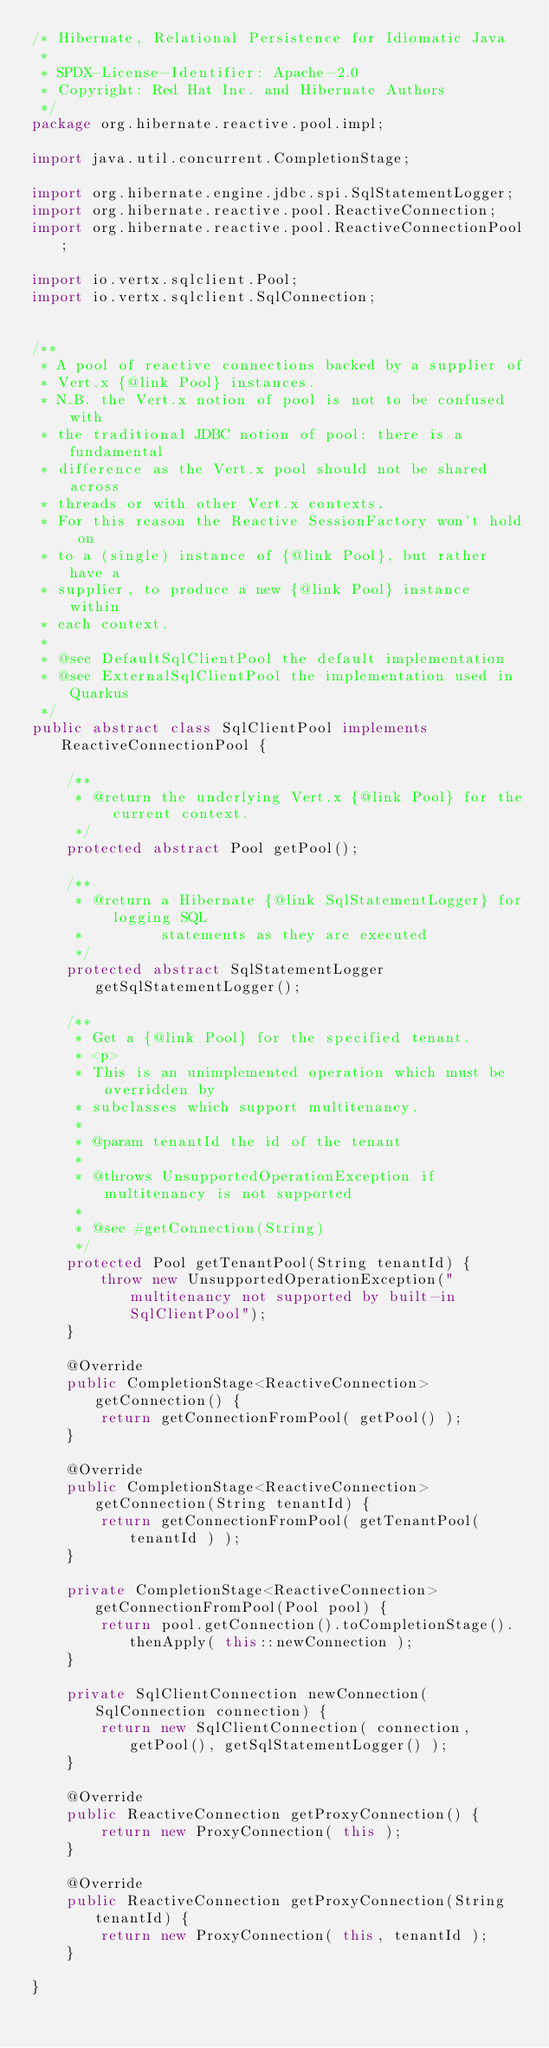<code> <loc_0><loc_0><loc_500><loc_500><_Java_>/* Hibernate, Relational Persistence for Idiomatic Java
 *
 * SPDX-License-Identifier: Apache-2.0
 * Copyright: Red Hat Inc. and Hibernate Authors
 */
package org.hibernate.reactive.pool.impl;

import java.util.concurrent.CompletionStage;

import org.hibernate.engine.jdbc.spi.SqlStatementLogger;
import org.hibernate.reactive.pool.ReactiveConnection;
import org.hibernate.reactive.pool.ReactiveConnectionPool;

import io.vertx.sqlclient.Pool;
import io.vertx.sqlclient.SqlConnection;


/**
 * A pool of reactive connections backed by a supplier of
 * Vert.x {@link Pool} instances.
 * N.B. the Vert.x notion of pool is not to be confused with
 * the traditional JDBC notion of pool: there is a fundamental
 * difference as the Vert.x pool should not be shared across
 * threads or with other Vert.x contexts.
 * For this reason the Reactive SessionFactory won't hold on
 * to a (single) instance of {@link Pool}, but rather have a
 * supplier, to produce a new {@link Pool} instance within
 * each context.
 *
 * @see DefaultSqlClientPool the default implementation
 * @see ExternalSqlClientPool the implementation used in Quarkus
 */
public abstract class SqlClientPool implements ReactiveConnectionPool {

	/**
	 * @return the underlying Vert.x {@link Pool} for the current context.
	 */
	protected abstract Pool getPool();

	/**
	 * @return a Hibernate {@link SqlStatementLogger} for logging SQL
	 *         statements as they are executed
	 */
	protected abstract SqlStatementLogger getSqlStatementLogger();

	/**
	 * Get a {@link Pool} for the specified tenant.
	 * <p>
	 * This is an unimplemented operation which must be overridden by
	 * subclasses which support multitenancy.
	 *
	 * @param tenantId the id of the tenant
	 *
	 * @throws UnsupportedOperationException if multitenancy is not supported
	 *
	 * @see #getConnection(String)
	 */
	protected Pool getTenantPool(String tenantId) {
		throw new UnsupportedOperationException("multitenancy not supported by built-in SqlClientPool");
	}

	@Override
	public CompletionStage<ReactiveConnection> getConnection() {
		return getConnectionFromPool( getPool() );
	}

	@Override
	public CompletionStage<ReactiveConnection> getConnection(String tenantId) {
		return getConnectionFromPool( getTenantPool( tenantId ) );
	}

	private CompletionStage<ReactiveConnection> getConnectionFromPool(Pool pool) {
		return pool.getConnection().toCompletionStage().thenApply( this::newConnection );
	}

	private SqlClientConnection newConnection(SqlConnection connection) {
		return new SqlClientConnection( connection, getPool(), getSqlStatementLogger() );
	}

	@Override
	public ReactiveConnection getProxyConnection() {
		return new ProxyConnection( this );
	}

	@Override
	public ReactiveConnection getProxyConnection(String tenantId) {
		return new ProxyConnection( this, tenantId );
	}

}
</code> 